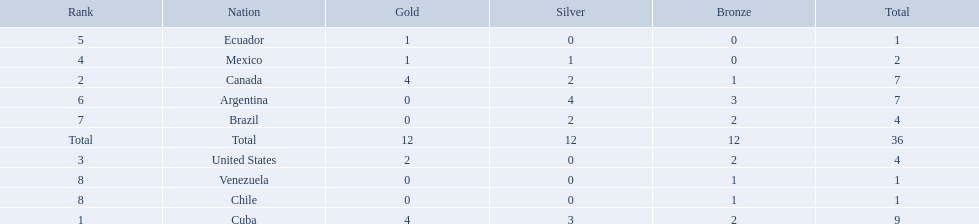Which countries won medals at the 2011 pan american games for the canoeing event? Cuba, Canada, United States, Mexico, Ecuador, Argentina, Brazil, Chile, Venezuela. Which of these countries won bronze medals? Cuba, Canada, United States, Argentina, Brazil, Chile, Venezuela. Of these countries, which won the most bronze medals? Argentina. 